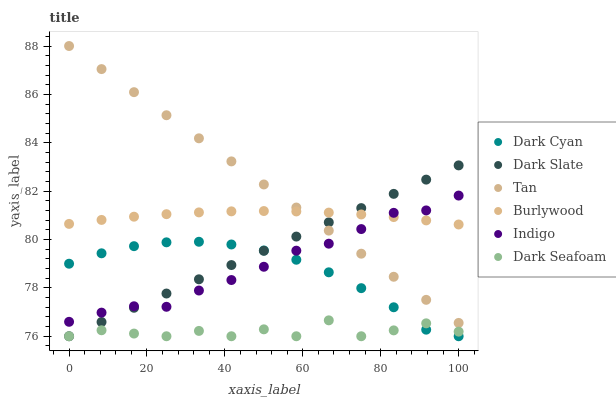Does Dark Seafoam have the minimum area under the curve?
Answer yes or no. Yes. Does Tan have the maximum area under the curve?
Answer yes or no. Yes. Does Burlywood have the minimum area under the curve?
Answer yes or no. No. Does Burlywood have the maximum area under the curve?
Answer yes or no. No. Is Tan the smoothest?
Answer yes or no. Yes. Is Dark Seafoam the roughest?
Answer yes or no. Yes. Is Burlywood the smoothest?
Answer yes or no. No. Is Burlywood the roughest?
Answer yes or no. No. Does Dark Slate have the lowest value?
Answer yes or no. Yes. Does Burlywood have the lowest value?
Answer yes or no. No. Does Tan have the highest value?
Answer yes or no. Yes. Does Burlywood have the highest value?
Answer yes or no. No. Is Dark Cyan less than Burlywood?
Answer yes or no. Yes. Is Tan greater than Dark Cyan?
Answer yes or no. Yes. Does Dark Seafoam intersect Dark Slate?
Answer yes or no. Yes. Is Dark Seafoam less than Dark Slate?
Answer yes or no. No. Is Dark Seafoam greater than Dark Slate?
Answer yes or no. No. Does Dark Cyan intersect Burlywood?
Answer yes or no. No. 